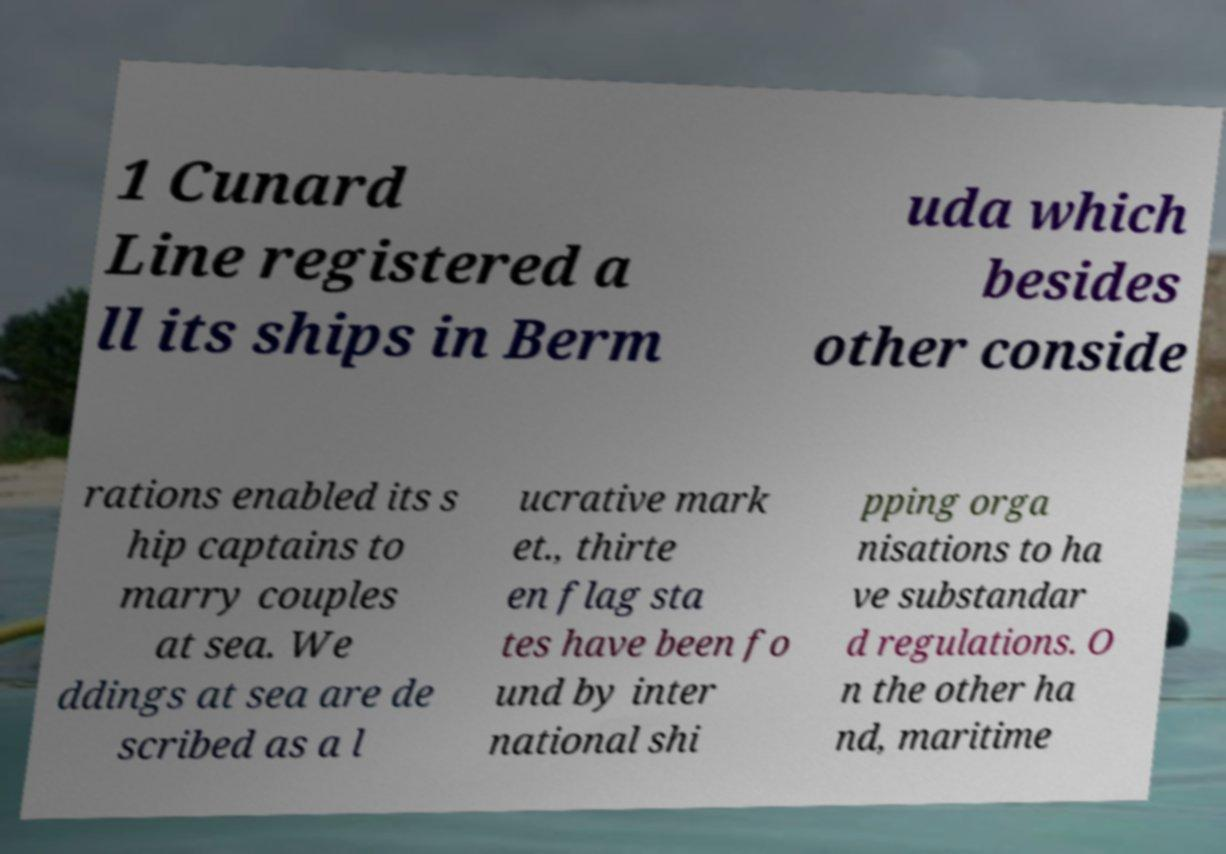Please identify and transcribe the text found in this image. 1 Cunard Line registered a ll its ships in Berm uda which besides other conside rations enabled its s hip captains to marry couples at sea. We ddings at sea are de scribed as a l ucrative mark et., thirte en flag sta tes have been fo und by inter national shi pping orga nisations to ha ve substandar d regulations. O n the other ha nd, maritime 